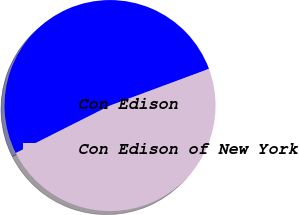<chart> <loc_0><loc_0><loc_500><loc_500><pie_chart><fcel>Con Edison<fcel>Con Edison of New York<nl><fcel>51.77%<fcel>48.23%<nl></chart> 